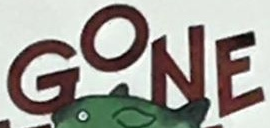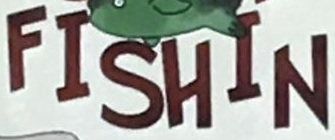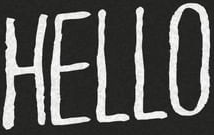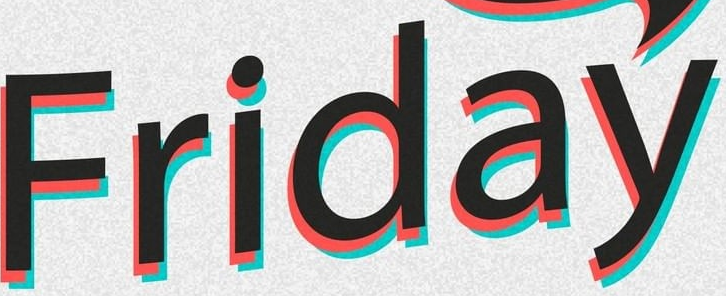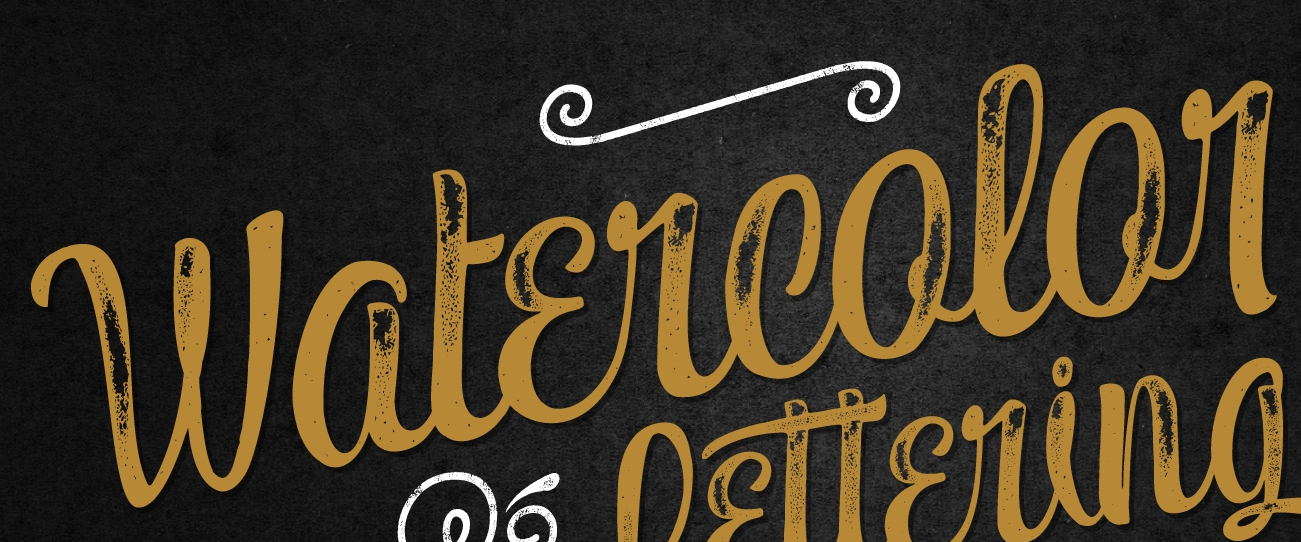Read the text content from these images in order, separated by a semicolon. GONE; FISHIN; HELLO; Friday; Watɛrcolor 